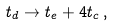<formula> <loc_0><loc_0><loc_500><loc_500>t _ { d } \rightarrow t _ { e } + 4 t _ { c } \, ,</formula> 